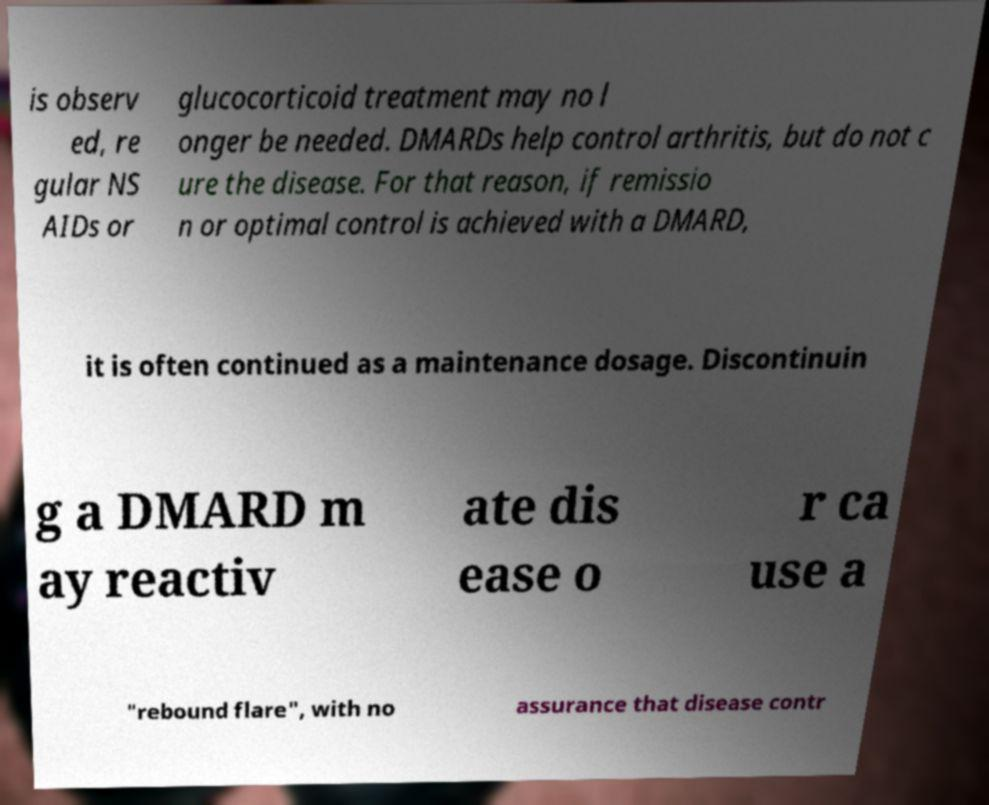Can you accurately transcribe the text from the provided image for me? is observ ed, re gular NS AIDs or glucocorticoid treatment may no l onger be needed. DMARDs help control arthritis, but do not c ure the disease. For that reason, if remissio n or optimal control is achieved with a DMARD, it is often continued as a maintenance dosage. Discontinuin g a DMARD m ay reactiv ate dis ease o r ca use a "rebound flare", with no assurance that disease contr 